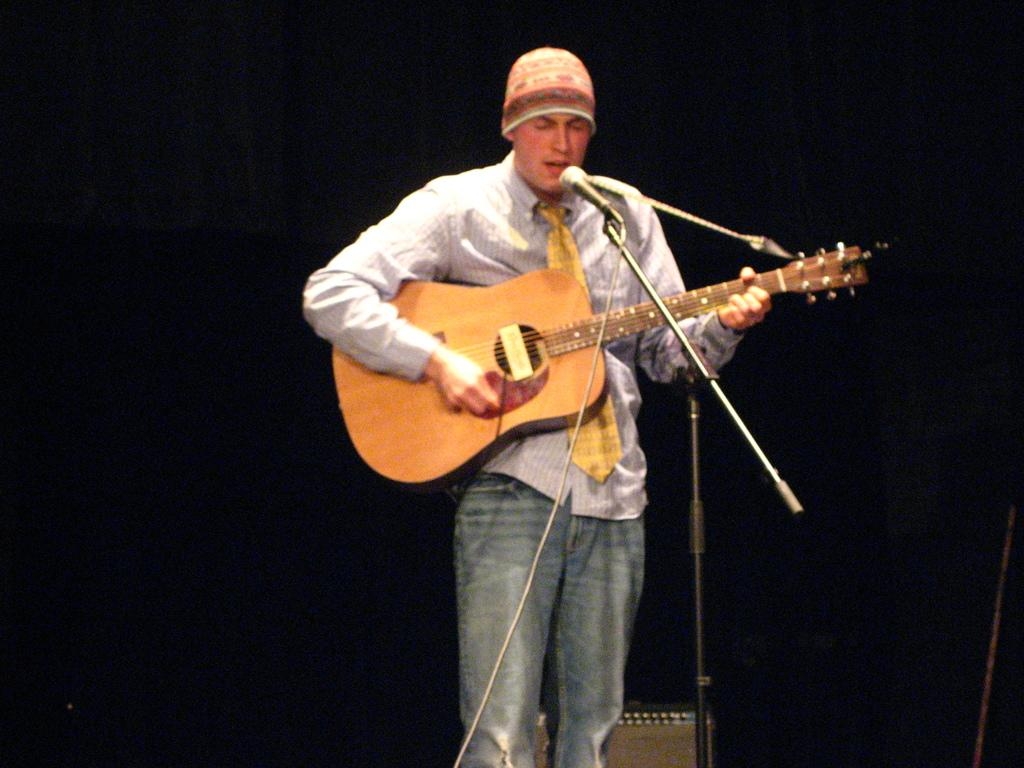What is the main subject of the image? There is a person standing in the center of the image. What is the person holding in the image? The person is holding a guitar. What object is in front of the person? There is a microphone in front of the person. How many trucks are parked behind the person in the image? There are no trucks visible in the image. What type of government policy is being discussed in the image? There is no discussion of government policy in the image; it features a person holding a guitar and standing near a microphone. 